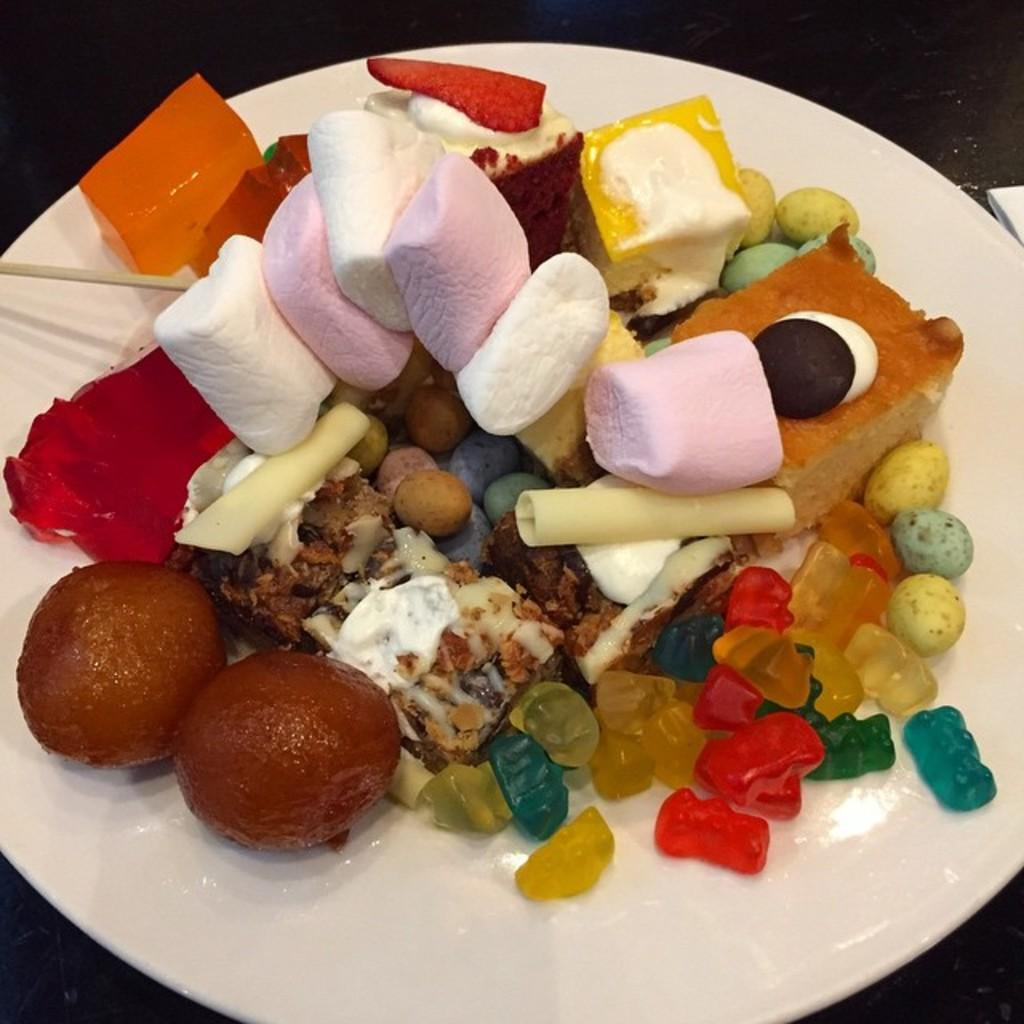What types of desserts can be seen in the image? There are jellies, marshmallows, cake, ice cream, and gulab jamuns in the image. Are there any other sweets visible besides the desserts mentioned? Yes, there are sweets on a plate in the image. Where are all these items located? All of these items are on a table. What type of jail can be seen in the image? There is no jail present in the image; it features desserts and sweets on a table. What causes shame in the image? There is no indication of shame or any negative emotion in the image; it is focused on desserts and sweets. 